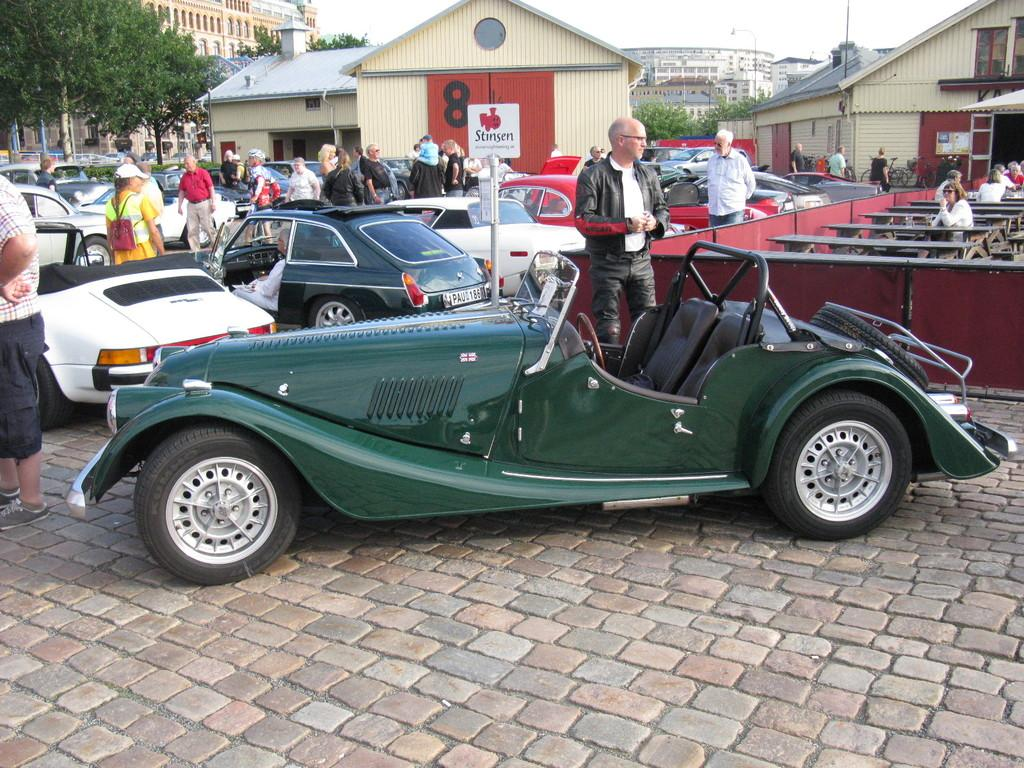What is the main subject of the image? The main subject of the image is a group of people standing. What else can be seen in the image? There are vehicles, buildings, and trees visible in the image. What is visible in the background of the image? The sky is visible in the background of the image. How many kittens are sitting on the paper in the image? There are no kittens or paper present in the image. 